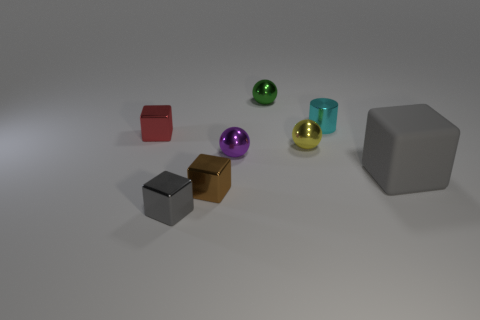Subtract all red cubes. How many cubes are left? 3 Subtract all brown cubes. How many cubes are left? 3 Add 1 tiny yellow spheres. How many objects exist? 9 Subtract all blue cubes. Subtract all gray cylinders. How many cubes are left? 4 Subtract all spheres. How many objects are left? 5 Add 1 small purple metallic things. How many small purple metallic things exist? 2 Subtract 0 yellow cylinders. How many objects are left? 8 Subtract all small metal cubes. Subtract all small brown shiny cubes. How many objects are left? 4 Add 4 tiny red things. How many tiny red things are left? 5 